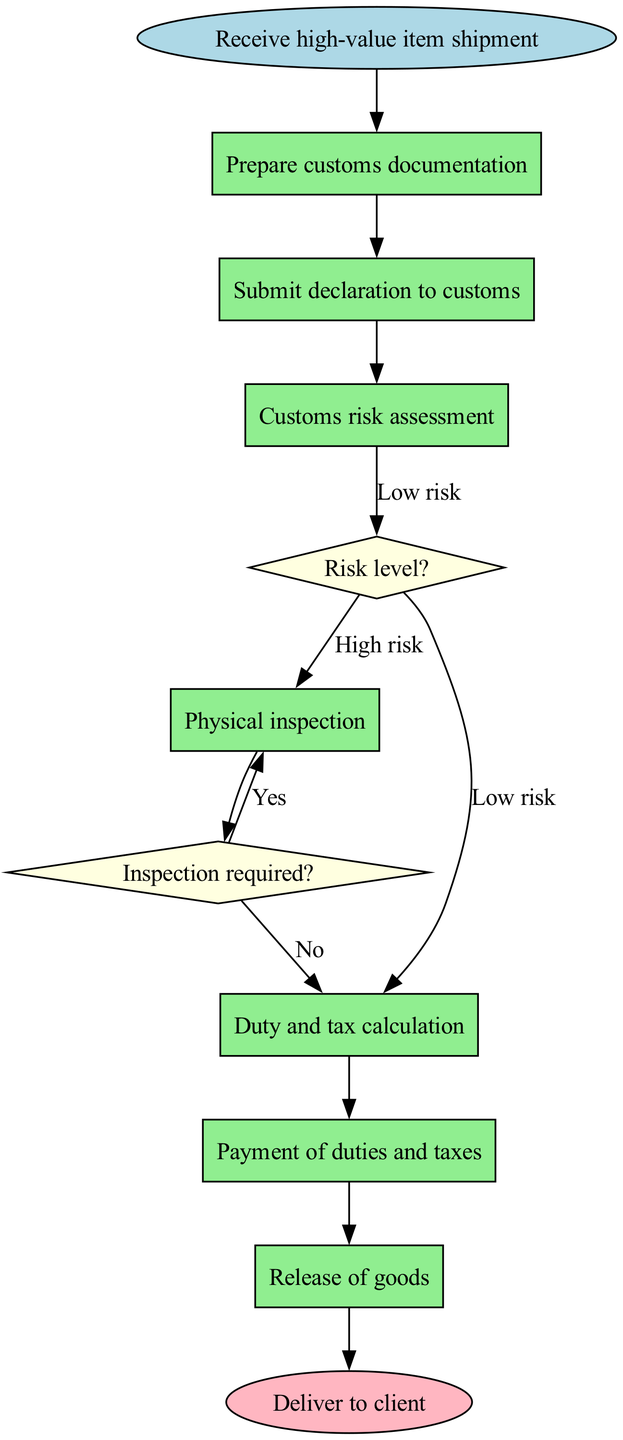What's the starting point of the customs clearance process? The starting point, indicated in the diagram, is labeled as "Receive high-value item shipment". This is the first action taken before any further steps can be initiated.
Answer: Receive high-value item shipment How many nodes are there in total? Counting the total components, we have one start node, seven process nodes, two decision nodes, and one end node, which sums up to eleven nodes in total.
Answer: eleven What does the "Payment of duties and taxes" node connect to? Examining the diagram, the "Payment of duties and taxes" node connects directly to the "Release of goods" node. This shows that payment is a prerequisite for the release.
Answer: Release of goods What happens if a high-value item is marked as "High risk"? If a high-value item is marked as "High risk", indicated by the flow in the diagram, it will lead to the "Physical inspection" node, where further inspection will take place before proceeding.
Answer: Physical inspection What is the final step after the clearance process? The end node represents the conclusion of the flowchart, which is "Deliver to client". This indicates that the goods are delivered to the client after all customs processes are completed.
Answer: Deliver to client If an item passes inspection, what is the next action? Following the "Inspection passed" outcome, the next action is listed as "Duty and tax calculation". This step is essential to determine the financial obligations before moving forward.
Answer: Duty and tax calculation What does the "Submit declaration to customs" node lead to? The "Submit declaration to customs" node leads directly to the "Customs risk assessment" node. This implies that after submission, the risk evaluation phase begins immediately.
Answer: Customs risk assessment What indicates that duties and taxes have been paid? The node labeled "Payment confirmed" indicates that the duties and taxes have been paid. It connects the payment process to the subsequent release of goods.
Answer: Payment confirmed What decision needs to be made after the customs risk assessment? After the customs risk assessment, the decision that needs to be made is the risk level, which determines if the inspection is required or not.
Answer: Risk level? 